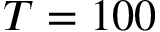Convert formula to latex. <formula><loc_0><loc_0><loc_500><loc_500>T = 1 0 0</formula> 